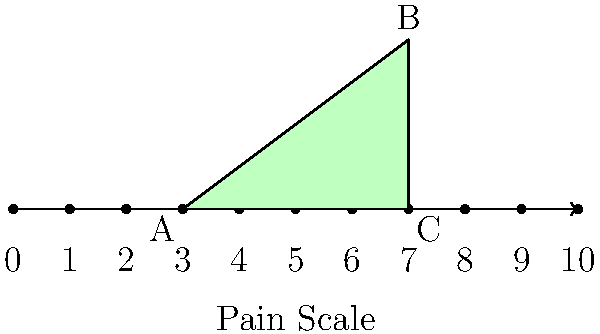In a pain scale diagram used for palliative care, a triangular region is highlighted to represent a patient's pain levels over time. The base of the triangle spans from 3 to 7 on a 0-10 pain scale, and the peak reaches a height of 3 units above the scale. If each unit on the pain scale represents 1 cm, what is the area of the highlighted triangular region in square centimeters? Let's approach this step-by-step:

1) First, we need to identify the dimensions of the triangle:
   - Base: It spans from 3 to 7 on the pain scale, so the length is 7 - 3 = 4 units
   - Height: The peak reaches 3 units above the scale

2) Given that each unit on the pain scale represents 1 cm, we can convert our dimensions:
   - Base = 4 cm
   - Height = 3 cm

3) The formula for the area of a triangle is:
   $$ A = \frac{1}{2} \times base \times height $$

4) Substituting our values:
   $$ A = \frac{1}{2} \times 4 \times 3 $$

5) Calculating:
   $$ A = \frac{1}{2} \times 12 = 6 $$

Therefore, the area of the highlighted triangular region is 6 square centimeters.
Answer: 6 cm² 